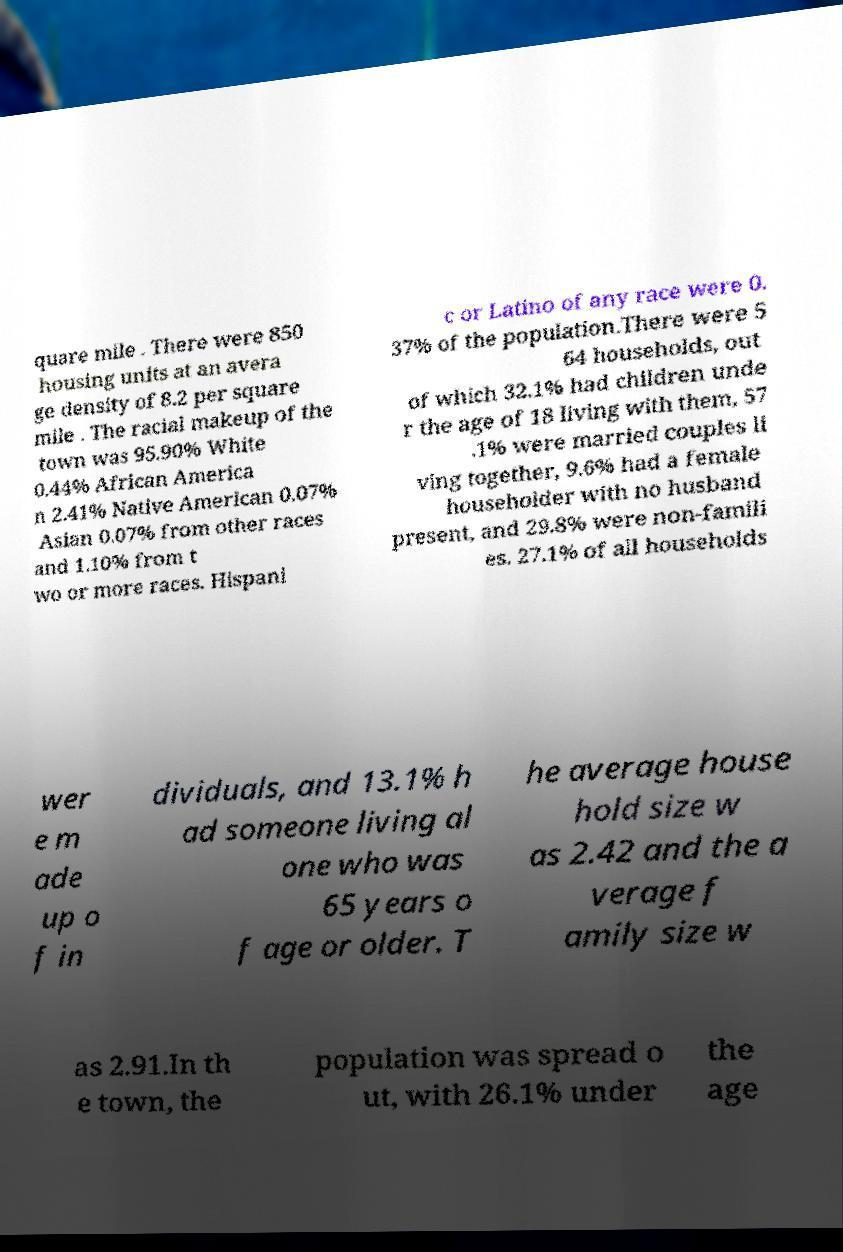What messages or text are displayed in this image? I need them in a readable, typed format. quare mile . There were 850 housing units at an avera ge density of 8.2 per square mile . The racial makeup of the town was 95.90% White 0.44% African America n 2.41% Native American 0.07% Asian 0.07% from other races and 1.10% from t wo or more races. Hispani c or Latino of any race were 0. 37% of the population.There were 5 64 households, out of which 32.1% had children unde r the age of 18 living with them, 57 .1% were married couples li ving together, 9.6% had a female householder with no husband present, and 29.8% were non-famili es. 27.1% of all households wer e m ade up o f in dividuals, and 13.1% h ad someone living al one who was 65 years o f age or older. T he average house hold size w as 2.42 and the a verage f amily size w as 2.91.In th e town, the population was spread o ut, with 26.1% under the age 